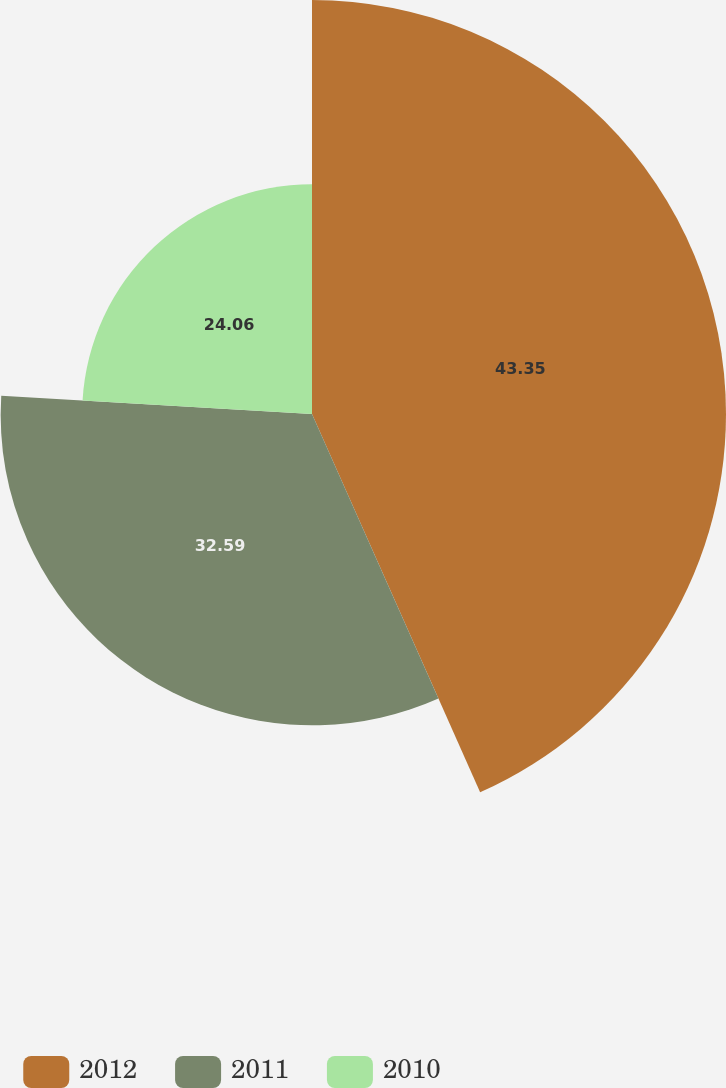<chart> <loc_0><loc_0><loc_500><loc_500><pie_chart><fcel>2012<fcel>2011<fcel>2010<nl><fcel>43.34%<fcel>32.59%<fcel>24.06%<nl></chart> 